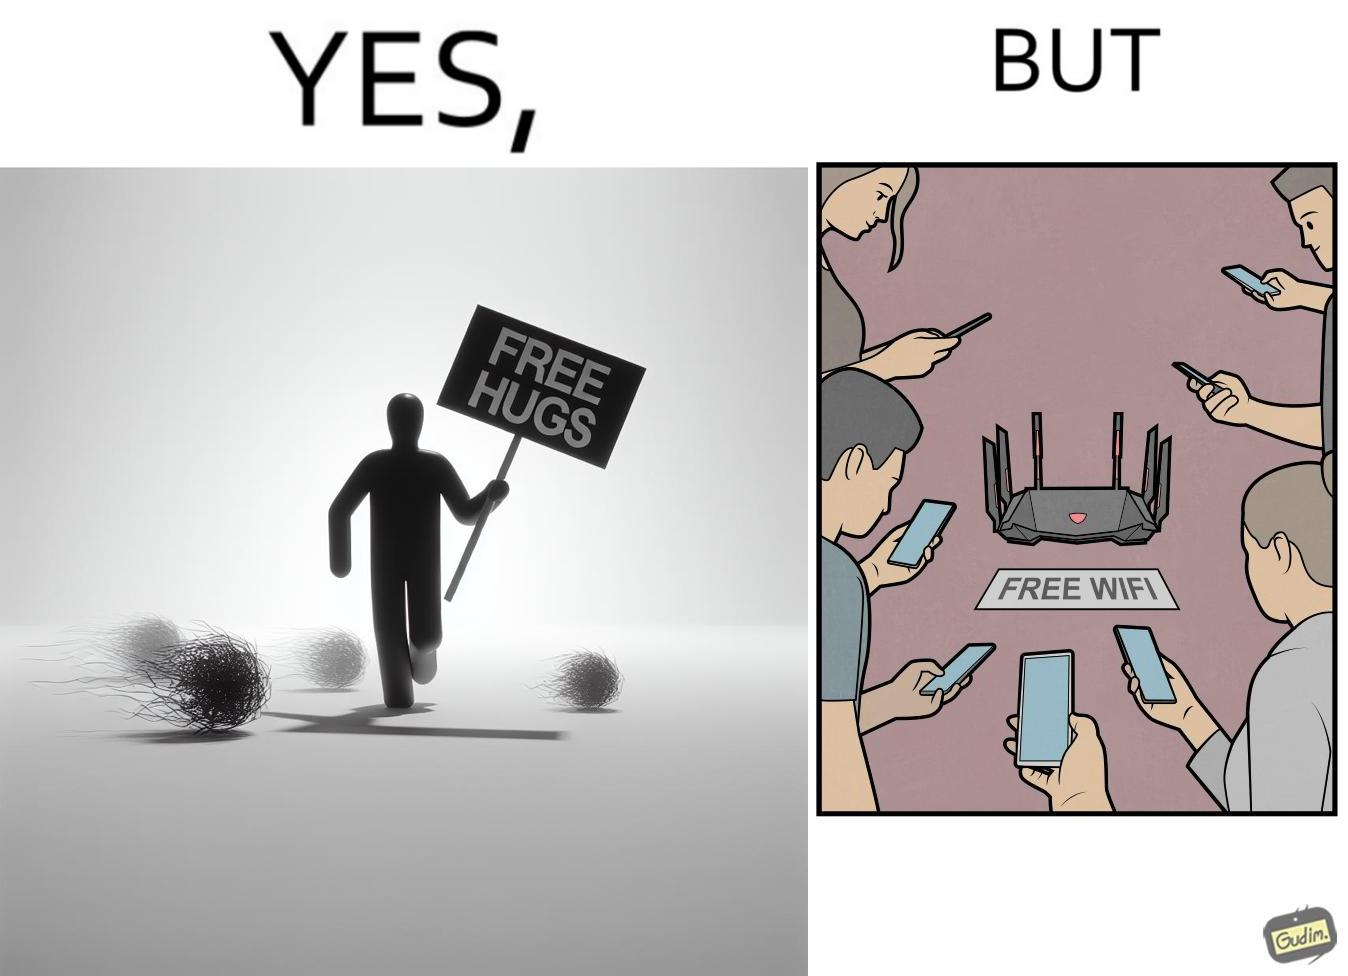What makes this image funny or satirical? This image is ironical, as a person holding up a "Free Hugs" sign is standing alone, while an inanimate Wi-fi Router giving "Free Wifi" is surrounded people trying to connect to it. This shows a growing lack of empathy in our society, while showing our increasing dependence on the digital devices in a virtual world. 